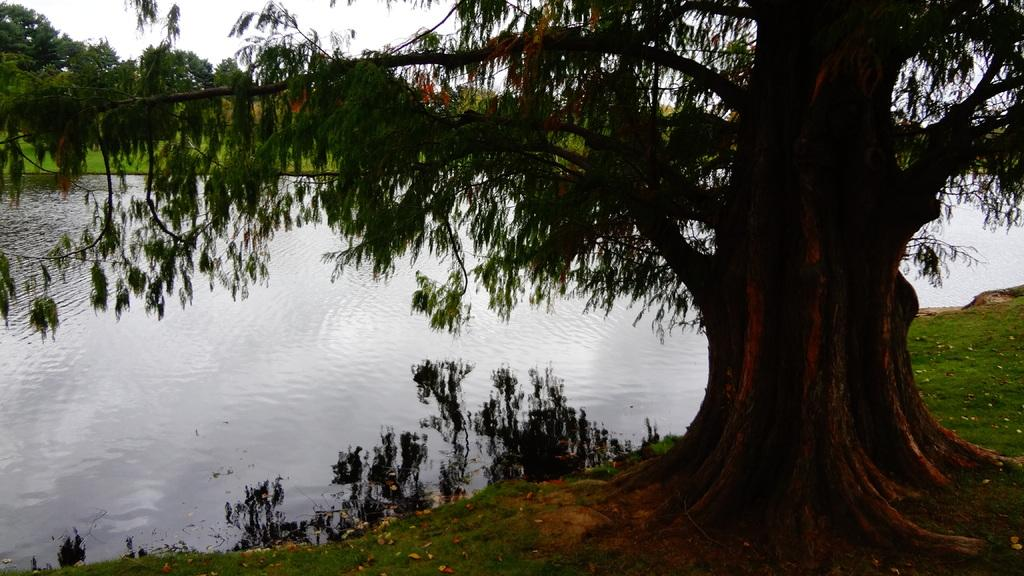What type of vegetation is on the right side of the image? There is a tree on the right side of the image. What can be seen on the left side of the image? There is water on the left side of the image. What is visible at the top of the image? The sky is visible at the top of the image. What type of rod can be seen falling into the water in the image? There is no rod or any object falling into the water in the image. What substance is present in the water in the image? The image does not provide information about any substances present in the water. 